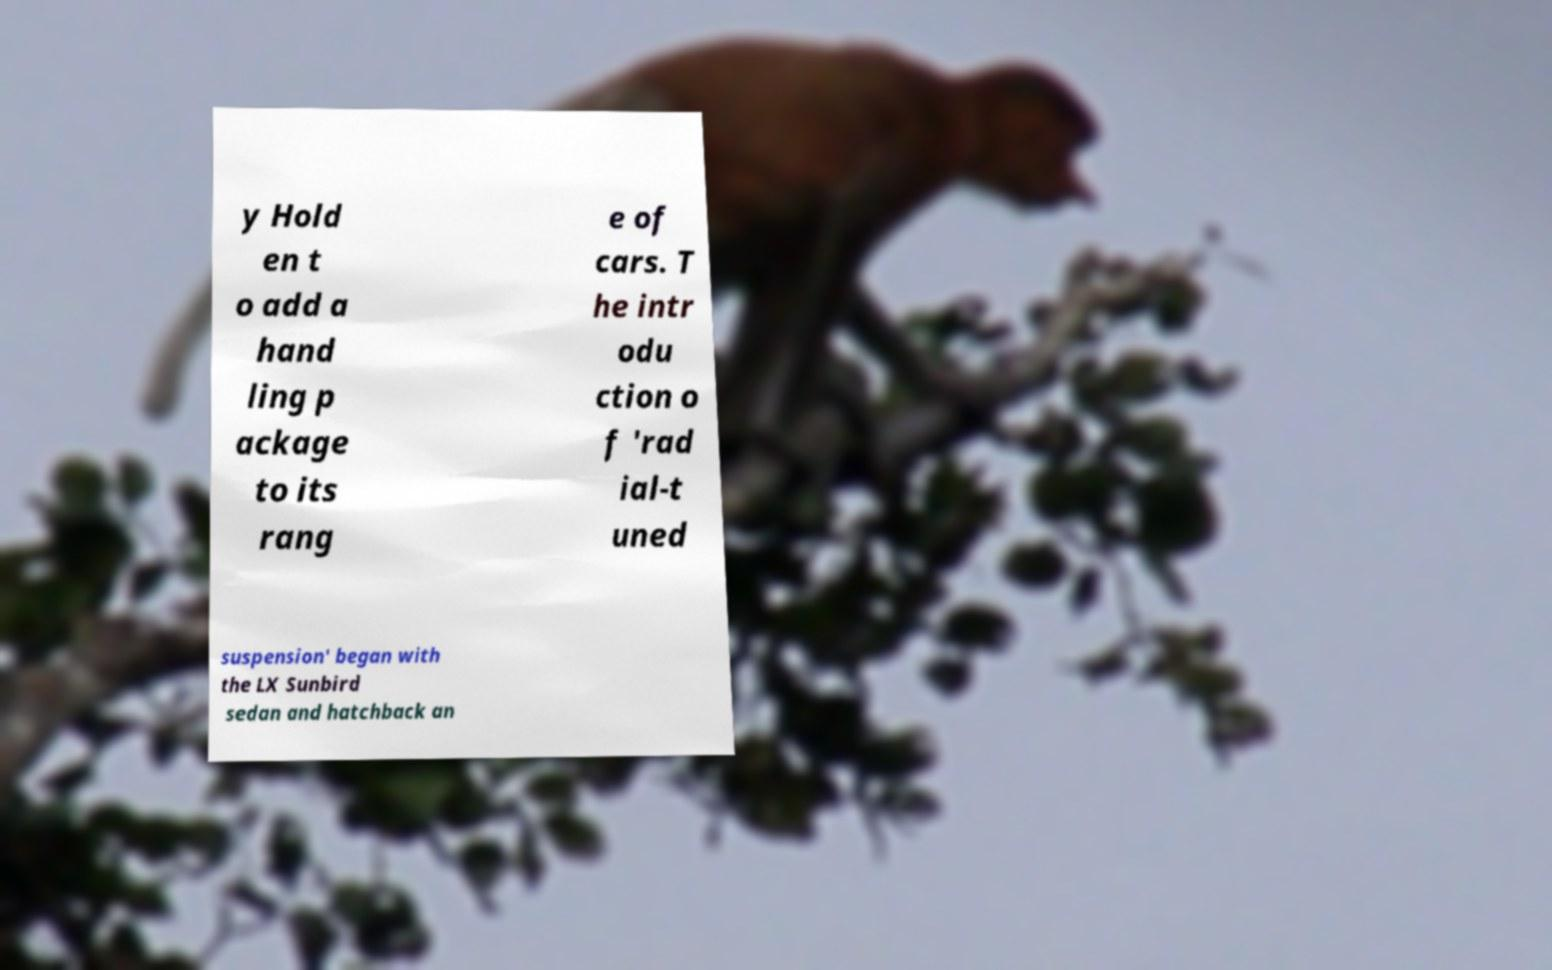What messages or text are displayed in this image? I need them in a readable, typed format. y Hold en t o add a hand ling p ackage to its rang e of cars. T he intr odu ction o f 'rad ial-t uned suspension' began with the LX Sunbird sedan and hatchback an 